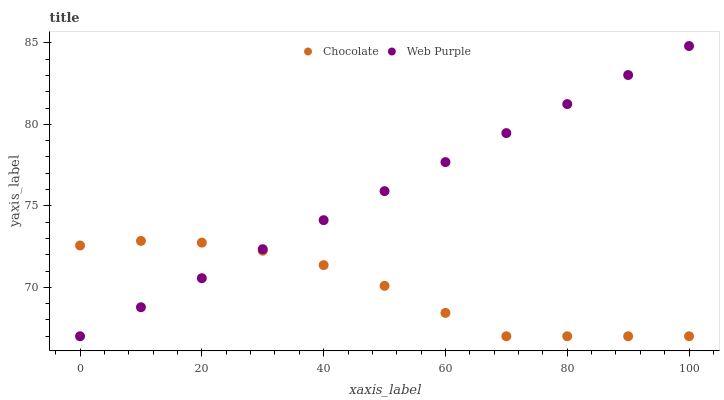Does Chocolate have the minimum area under the curve?
Answer yes or no. Yes. Does Web Purple have the maximum area under the curve?
Answer yes or no. Yes. Does Chocolate have the maximum area under the curve?
Answer yes or no. No. Is Web Purple the smoothest?
Answer yes or no. Yes. Is Chocolate the roughest?
Answer yes or no. Yes. Is Chocolate the smoothest?
Answer yes or no. No. Does Web Purple have the lowest value?
Answer yes or no. Yes. Does Web Purple have the highest value?
Answer yes or no. Yes. Does Chocolate have the highest value?
Answer yes or no. No. Does Web Purple intersect Chocolate?
Answer yes or no. Yes. Is Web Purple less than Chocolate?
Answer yes or no. No. Is Web Purple greater than Chocolate?
Answer yes or no. No. 